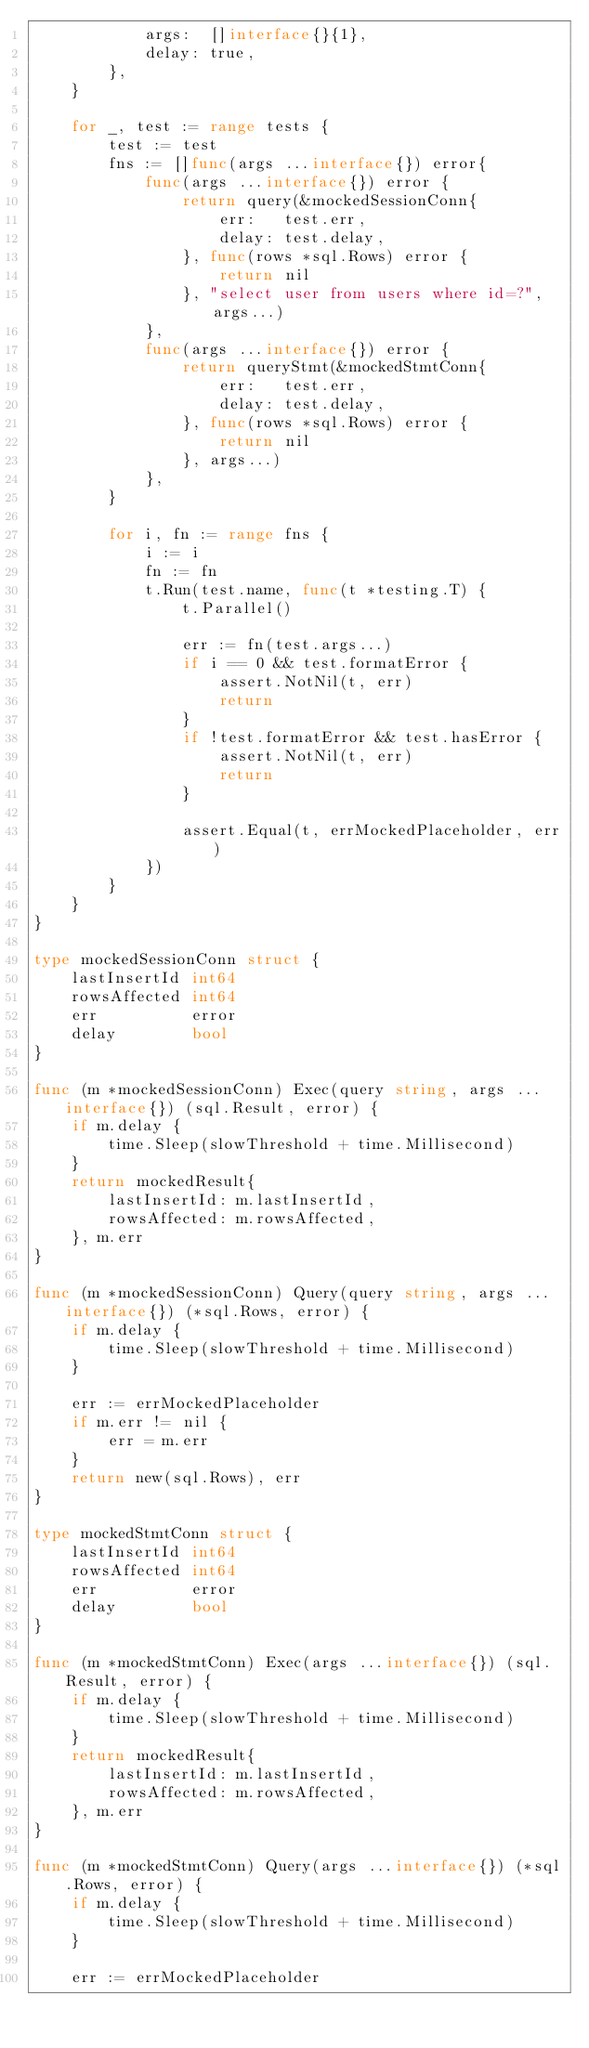Convert code to text. <code><loc_0><loc_0><loc_500><loc_500><_Go_>			args:  []interface{}{1},
			delay: true,
		},
	}

	for _, test := range tests {
		test := test
		fns := []func(args ...interface{}) error{
			func(args ...interface{}) error {
				return query(&mockedSessionConn{
					err:   test.err,
					delay: test.delay,
				}, func(rows *sql.Rows) error {
					return nil
				}, "select user from users where id=?", args...)
			},
			func(args ...interface{}) error {
				return queryStmt(&mockedStmtConn{
					err:   test.err,
					delay: test.delay,
				}, func(rows *sql.Rows) error {
					return nil
				}, args...)
			},
		}

		for i, fn := range fns {
			i := i
			fn := fn
			t.Run(test.name, func(t *testing.T) {
				t.Parallel()

				err := fn(test.args...)
				if i == 0 && test.formatError {
					assert.NotNil(t, err)
					return
				}
				if !test.formatError && test.hasError {
					assert.NotNil(t, err)
					return
				}

				assert.Equal(t, errMockedPlaceholder, err)
			})
		}
	}
}

type mockedSessionConn struct {
	lastInsertId int64
	rowsAffected int64
	err          error
	delay        bool
}

func (m *mockedSessionConn) Exec(query string, args ...interface{}) (sql.Result, error) {
	if m.delay {
		time.Sleep(slowThreshold + time.Millisecond)
	}
	return mockedResult{
		lastInsertId: m.lastInsertId,
		rowsAffected: m.rowsAffected,
	}, m.err
}

func (m *mockedSessionConn) Query(query string, args ...interface{}) (*sql.Rows, error) {
	if m.delay {
		time.Sleep(slowThreshold + time.Millisecond)
	}

	err := errMockedPlaceholder
	if m.err != nil {
		err = m.err
	}
	return new(sql.Rows), err
}

type mockedStmtConn struct {
	lastInsertId int64
	rowsAffected int64
	err          error
	delay        bool
}

func (m *mockedStmtConn) Exec(args ...interface{}) (sql.Result, error) {
	if m.delay {
		time.Sleep(slowThreshold + time.Millisecond)
	}
	return mockedResult{
		lastInsertId: m.lastInsertId,
		rowsAffected: m.rowsAffected,
	}, m.err
}

func (m *mockedStmtConn) Query(args ...interface{}) (*sql.Rows, error) {
	if m.delay {
		time.Sleep(slowThreshold + time.Millisecond)
	}

	err := errMockedPlaceholder</code> 